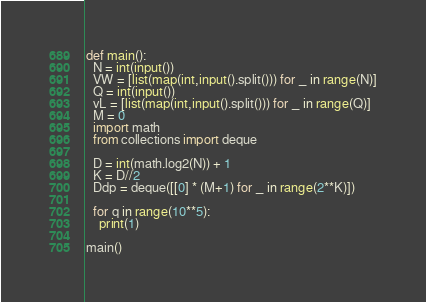Convert code to text. <code><loc_0><loc_0><loc_500><loc_500><_Python_>def main():  
  N = int(input())
  VW = [list(map(int,input().split())) for _ in range(N)]
  Q = int(input())
  vL = [list(map(int,input().split())) for _ in range(Q)]
  M = 0
  import math
  from collections import deque

  D = int(math.log2(N)) + 1
  K = D//2
  Ddp = deque([[0] * (M+1) for _ in range(2**K)])

  for q in range(10**5):
    print(1)
    
main()
</code> 